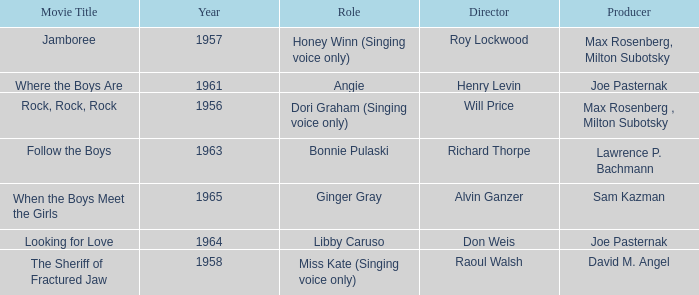What movie was made in 1957? Jamboree. 